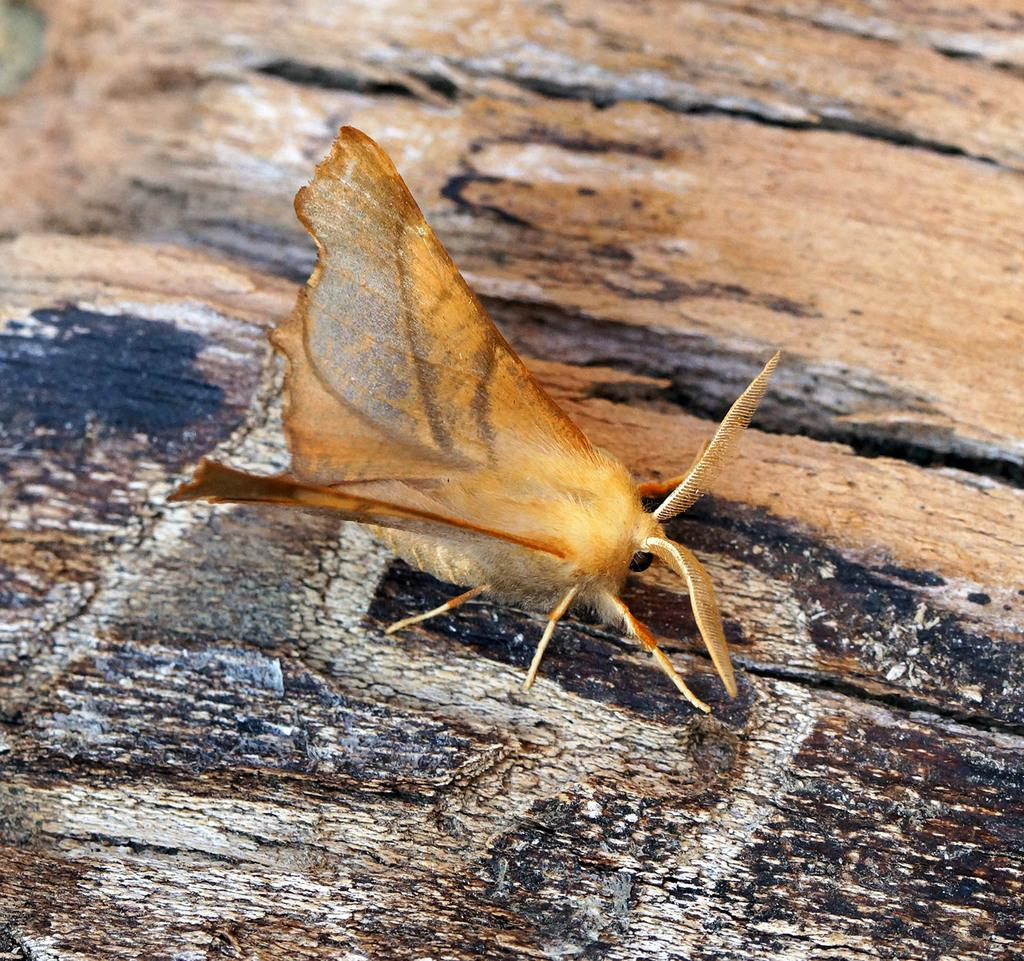What is the main subject of the image? There is a butterfly in the image. What type of surface is the butterfly on? The butterfly is on a wooden surface. What is the tax rate for the store in the image? There is no store present in the image, so it is not possible to determine the tax rate. 